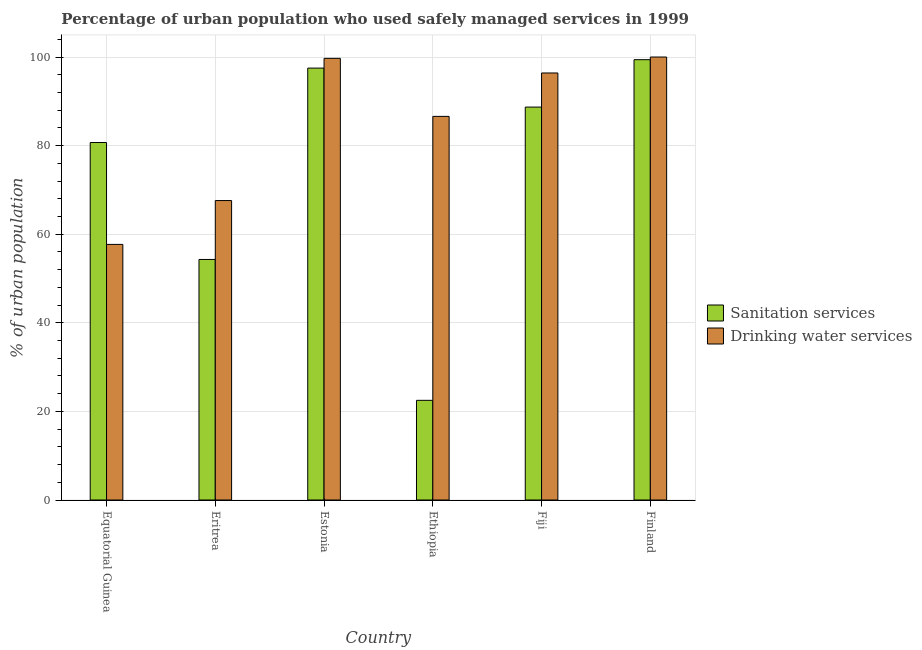How many groups of bars are there?
Give a very brief answer. 6. Are the number of bars per tick equal to the number of legend labels?
Make the answer very short. Yes. How many bars are there on the 5th tick from the right?
Make the answer very short. 2. What is the label of the 1st group of bars from the left?
Give a very brief answer. Equatorial Guinea. What is the percentage of urban population who used drinking water services in Eritrea?
Provide a short and direct response. 67.6. Across all countries, what is the maximum percentage of urban population who used sanitation services?
Provide a short and direct response. 99.4. In which country was the percentage of urban population who used drinking water services minimum?
Keep it short and to the point. Equatorial Guinea. What is the total percentage of urban population who used sanitation services in the graph?
Your response must be concise. 443.1. What is the difference between the percentage of urban population who used sanitation services in Equatorial Guinea and that in Eritrea?
Provide a succinct answer. 26.4. What is the difference between the percentage of urban population who used drinking water services in Finland and the percentage of urban population who used sanitation services in Ethiopia?
Keep it short and to the point. 77.5. What is the average percentage of urban population who used sanitation services per country?
Ensure brevity in your answer.  73.85. What is the difference between the percentage of urban population who used drinking water services and percentage of urban population who used sanitation services in Ethiopia?
Your answer should be very brief. 64.1. In how many countries, is the percentage of urban population who used drinking water services greater than 84 %?
Offer a very short reply. 4. What is the ratio of the percentage of urban population who used drinking water services in Equatorial Guinea to that in Fiji?
Provide a succinct answer. 0.6. What is the difference between the highest and the second highest percentage of urban population who used drinking water services?
Ensure brevity in your answer.  0.3. What is the difference between the highest and the lowest percentage of urban population who used drinking water services?
Your answer should be compact. 42.3. In how many countries, is the percentage of urban population who used drinking water services greater than the average percentage of urban population who used drinking water services taken over all countries?
Offer a very short reply. 4. What does the 1st bar from the left in Eritrea represents?
Give a very brief answer. Sanitation services. What does the 1st bar from the right in Ethiopia represents?
Your answer should be very brief. Drinking water services. How many bars are there?
Your answer should be very brief. 12. How many countries are there in the graph?
Keep it short and to the point. 6. Does the graph contain grids?
Give a very brief answer. Yes. How many legend labels are there?
Your response must be concise. 2. What is the title of the graph?
Offer a terse response. Percentage of urban population who used safely managed services in 1999. What is the label or title of the Y-axis?
Make the answer very short. % of urban population. What is the % of urban population in Sanitation services in Equatorial Guinea?
Your answer should be compact. 80.7. What is the % of urban population in Drinking water services in Equatorial Guinea?
Make the answer very short. 57.7. What is the % of urban population in Sanitation services in Eritrea?
Offer a terse response. 54.3. What is the % of urban population of Drinking water services in Eritrea?
Your answer should be very brief. 67.6. What is the % of urban population of Sanitation services in Estonia?
Offer a terse response. 97.5. What is the % of urban population of Drinking water services in Estonia?
Offer a terse response. 99.7. What is the % of urban population of Drinking water services in Ethiopia?
Your answer should be very brief. 86.6. What is the % of urban population in Sanitation services in Fiji?
Ensure brevity in your answer.  88.7. What is the % of urban population of Drinking water services in Fiji?
Offer a very short reply. 96.4. What is the % of urban population of Sanitation services in Finland?
Your response must be concise. 99.4. Across all countries, what is the maximum % of urban population in Sanitation services?
Offer a very short reply. 99.4. Across all countries, what is the minimum % of urban population in Sanitation services?
Your answer should be very brief. 22.5. Across all countries, what is the minimum % of urban population in Drinking water services?
Give a very brief answer. 57.7. What is the total % of urban population of Sanitation services in the graph?
Give a very brief answer. 443.1. What is the total % of urban population in Drinking water services in the graph?
Provide a succinct answer. 508. What is the difference between the % of urban population in Sanitation services in Equatorial Guinea and that in Eritrea?
Give a very brief answer. 26.4. What is the difference between the % of urban population in Drinking water services in Equatorial Guinea and that in Eritrea?
Ensure brevity in your answer.  -9.9. What is the difference between the % of urban population of Sanitation services in Equatorial Guinea and that in Estonia?
Offer a very short reply. -16.8. What is the difference between the % of urban population of Drinking water services in Equatorial Guinea and that in Estonia?
Ensure brevity in your answer.  -42. What is the difference between the % of urban population in Sanitation services in Equatorial Guinea and that in Ethiopia?
Your answer should be compact. 58.2. What is the difference between the % of urban population of Drinking water services in Equatorial Guinea and that in Ethiopia?
Ensure brevity in your answer.  -28.9. What is the difference between the % of urban population of Drinking water services in Equatorial Guinea and that in Fiji?
Provide a succinct answer. -38.7. What is the difference between the % of urban population in Sanitation services in Equatorial Guinea and that in Finland?
Your answer should be very brief. -18.7. What is the difference between the % of urban population of Drinking water services in Equatorial Guinea and that in Finland?
Your answer should be very brief. -42.3. What is the difference between the % of urban population of Sanitation services in Eritrea and that in Estonia?
Ensure brevity in your answer.  -43.2. What is the difference between the % of urban population in Drinking water services in Eritrea and that in Estonia?
Your answer should be very brief. -32.1. What is the difference between the % of urban population in Sanitation services in Eritrea and that in Ethiopia?
Ensure brevity in your answer.  31.8. What is the difference between the % of urban population of Drinking water services in Eritrea and that in Ethiopia?
Your answer should be very brief. -19. What is the difference between the % of urban population of Sanitation services in Eritrea and that in Fiji?
Your answer should be very brief. -34.4. What is the difference between the % of urban population of Drinking water services in Eritrea and that in Fiji?
Offer a very short reply. -28.8. What is the difference between the % of urban population of Sanitation services in Eritrea and that in Finland?
Give a very brief answer. -45.1. What is the difference between the % of urban population in Drinking water services in Eritrea and that in Finland?
Your answer should be very brief. -32.4. What is the difference between the % of urban population in Sanitation services in Estonia and that in Ethiopia?
Make the answer very short. 75. What is the difference between the % of urban population of Drinking water services in Estonia and that in Ethiopia?
Ensure brevity in your answer.  13.1. What is the difference between the % of urban population of Sanitation services in Estonia and that in Fiji?
Offer a terse response. 8.8. What is the difference between the % of urban population in Drinking water services in Estonia and that in Fiji?
Offer a terse response. 3.3. What is the difference between the % of urban population in Sanitation services in Ethiopia and that in Fiji?
Ensure brevity in your answer.  -66.2. What is the difference between the % of urban population in Sanitation services in Ethiopia and that in Finland?
Provide a short and direct response. -76.9. What is the difference between the % of urban population in Drinking water services in Fiji and that in Finland?
Your answer should be compact. -3.6. What is the difference between the % of urban population in Sanitation services in Equatorial Guinea and the % of urban population in Drinking water services in Eritrea?
Give a very brief answer. 13.1. What is the difference between the % of urban population of Sanitation services in Equatorial Guinea and the % of urban population of Drinking water services in Estonia?
Offer a very short reply. -19. What is the difference between the % of urban population in Sanitation services in Equatorial Guinea and the % of urban population in Drinking water services in Ethiopia?
Provide a short and direct response. -5.9. What is the difference between the % of urban population of Sanitation services in Equatorial Guinea and the % of urban population of Drinking water services in Fiji?
Give a very brief answer. -15.7. What is the difference between the % of urban population in Sanitation services in Equatorial Guinea and the % of urban population in Drinking water services in Finland?
Your response must be concise. -19.3. What is the difference between the % of urban population of Sanitation services in Eritrea and the % of urban population of Drinking water services in Estonia?
Your answer should be very brief. -45.4. What is the difference between the % of urban population of Sanitation services in Eritrea and the % of urban population of Drinking water services in Ethiopia?
Provide a short and direct response. -32.3. What is the difference between the % of urban population in Sanitation services in Eritrea and the % of urban population in Drinking water services in Fiji?
Provide a succinct answer. -42.1. What is the difference between the % of urban population in Sanitation services in Eritrea and the % of urban population in Drinking water services in Finland?
Provide a short and direct response. -45.7. What is the difference between the % of urban population in Sanitation services in Ethiopia and the % of urban population in Drinking water services in Fiji?
Your answer should be very brief. -73.9. What is the difference between the % of urban population in Sanitation services in Ethiopia and the % of urban population in Drinking water services in Finland?
Make the answer very short. -77.5. What is the difference between the % of urban population in Sanitation services in Fiji and the % of urban population in Drinking water services in Finland?
Offer a very short reply. -11.3. What is the average % of urban population in Sanitation services per country?
Provide a short and direct response. 73.85. What is the average % of urban population in Drinking water services per country?
Offer a terse response. 84.67. What is the difference between the % of urban population in Sanitation services and % of urban population in Drinking water services in Eritrea?
Offer a very short reply. -13.3. What is the difference between the % of urban population in Sanitation services and % of urban population in Drinking water services in Ethiopia?
Your answer should be very brief. -64.1. What is the difference between the % of urban population of Sanitation services and % of urban population of Drinking water services in Finland?
Your answer should be compact. -0.6. What is the ratio of the % of urban population of Sanitation services in Equatorial Guinea to that in Eritrea?
Provide a short and direct response. 1.49. What is the ratio of the % of urban population of Drinking water services in Equatorial Guinea to that in Eritrea?
Offer a very short reply. 0.85. What is the ratio of the % of urban population of Sanitation services in Equatorial Guinea to that in Estonia?
Ensure brevity in your answer.  0.83. What is the ratio of the % of urban population in Drinking water services in Equatorial Guinea to that in Estonia?
Offer a very short reply. 0.58. What is the ratio of the % of urban population of Sanitation services in Equatorial Guinea to that in Ethiopia?
Provide a short and direct response. 3.59. What is the ratio of the % of urban population of Drinking water services in Equatorial Guinea to that in Ethiopia?
Make the answer very short. 0.67. What is the ratio of the % of urban population of Sanitation services in Equatorial Guinea to that in Fiji?
Make the answer very short. 0.91. What is the ratio of the % of urban population in Drinking water services in Equatorial Guinea to that in Fiji?
Provide a succinct answer. 0.6. What is the ratio of the % of urban population of Sanitation services in Equatorial Guinea to that in Finland?
Offer a very short reply. 0.81. What is the ratio of the % of urban population in Drinking water services in Equatorial Guinea to that in Finland?
Offer a very short reply. 0.58. What is the ratio of the % of urban population of Sanitation services in Eritrea to that in Estonia?
Provide a short and direct response. 0.56. What is the ratio of the % of urban population in Drinking water services in Eritrea to that in Estonia?
Give a very brief answer. 0.68. What is the ratio of the % of urban population in Sanitation services in Eritrea to that in Ethiopia?
Offer a very short reply. 2.41. What is the ratio of the % of urban population in Drinking water services in Eritrea to that in Ethiopia?
Offer a very short reply. 0.78. What is the ratio of the % of urban population of Sanitation services in Eritrea to that in Fiji?
Provide a short and direct response. 0.61. What is the ratio of the % of urban population in Drinking water services in Eritrea to that in Fiji?
Your answer should be very brief. 0.7. What is the ratio of the % of urban population of Sanitation services in Eritrea to that in Finland?
Provide a succinct answer. 0.55. What is the ratio of the % of urban population in Drinking water services in Eritrea to that in Finland?
Your answer should be very brief. 0.68. What is the ratio of the % of urban population of Sanitation services in Estonia to that in Ethiopia?
Your answer should be very brief. 4.33. What is the ratio of the % of urban population of Drinking water services in Estonia to that in Ethiopia?
Ensure brevity in your answer.  1.15. What is the ratio of the % of urban population in Sanitation services in Estonia to that in Fiji?
Your response must be concise. 1.1. What is the ratio of the % of urban population in Drinking water services in Estonia to that in Fiji?
Keep it short and to the point. 1.03. What is the ratio of the % of urban population of Sanitation services in Estonia to that in Finland?
Offer a very short reply. 0.98. What is the ratio of the % of urban population of Drinking water services in Estonia to that in Finland?
Ensure brevity in your answer.  1. What is the ratio of the % of urban population of Sanitation services in Ethiopia to that in Fiji?
Your response must be concise. 0.25. What is the ratio of the % of urban population in Drinking water services in Ethiopia to that in Fiji?
Provide a short and direct response. 0.9. What is the ratio of the % of urban population of Sanitation services in Ethiopia to that in Finland?
Offer a terse response. 0.23. What is the ratio of the % of urban population in Drinking water services in Ethiopia to that in Finland?
Your answer should be compact. 0.87. What is the ratio of the % of urban population of Sanitation services in Fiji to that in Finland?
Your answer should be compact. 0.89. What is the ratio of the % of urban population of Drinking water services in Fiji to that in Finland?
Give a very brief answer. 0.96. What is the difference between the highest and the second highest % of urban population of Sanitation services?
Provide a succinct answer. 1.9. What is the difference between the highest and the second highest % of urban population of Drinking water services?
Give a very brief answer. 0.3. What is the difference between the highest and the lowest % of urban population of Sanitation services?
Give a very brief answer. 76.9. What is the difference between the highest and the lowest % of urban population in Drinking water services?
Give a very brief answer. 42.3. 